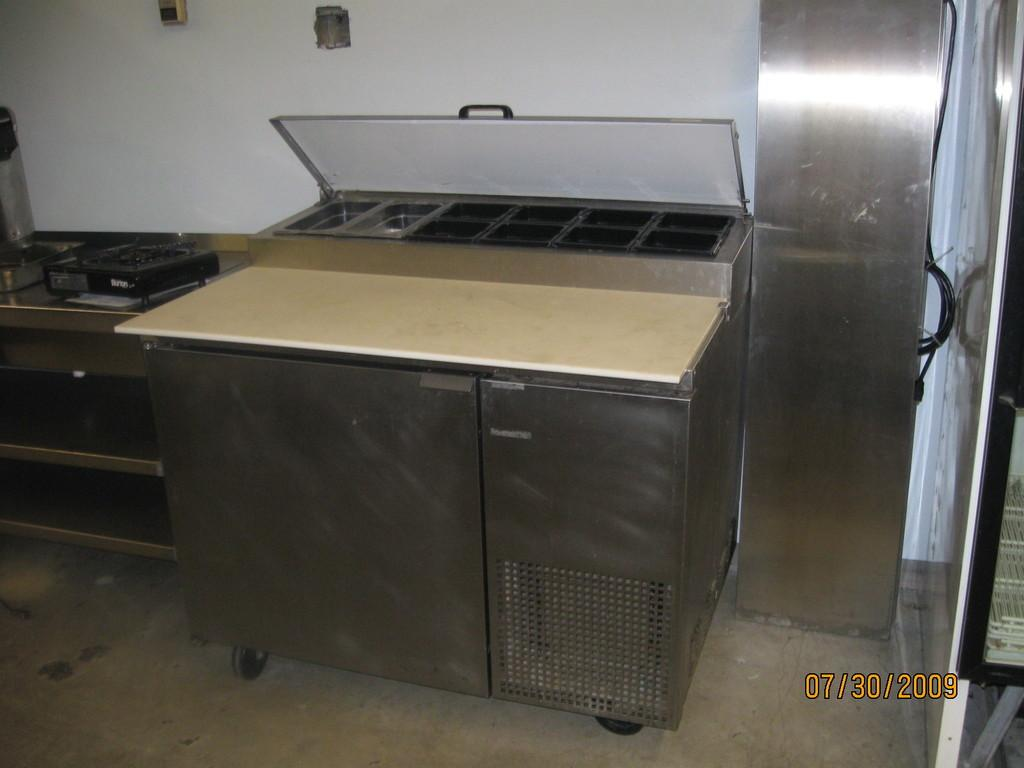Provide a one-sentence caption for the provided image. A clean stainless steel Ban Marie sits in an empty kitchen. 